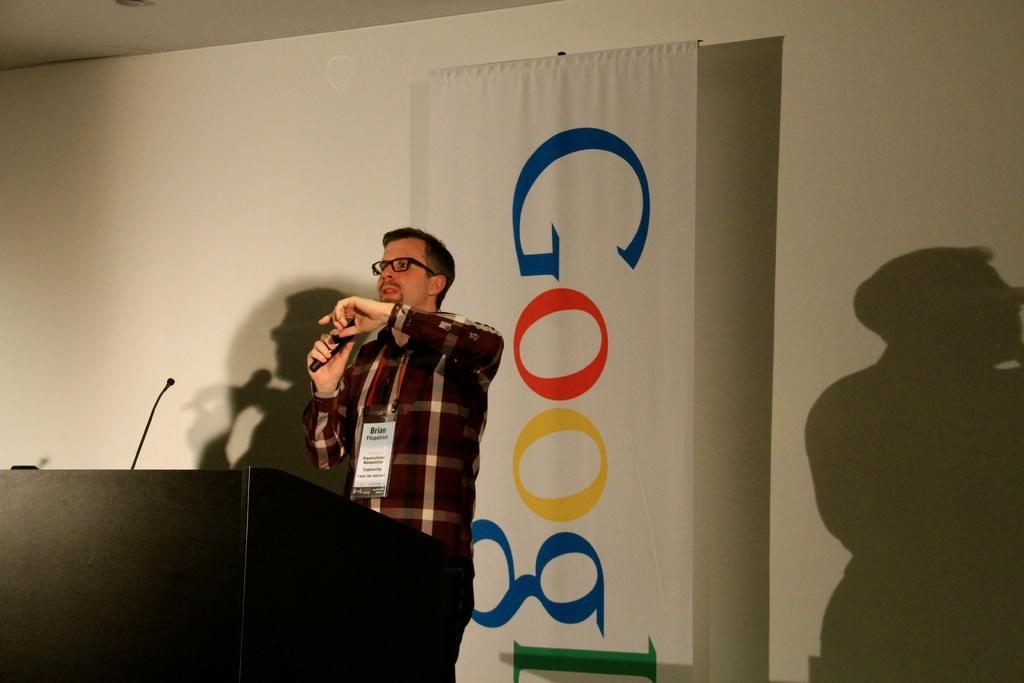How would you summarize this image in a sentence or two? This picture shows man standing and speaking with the help of a microphone at a podium and we see a banner hanging on the back. 